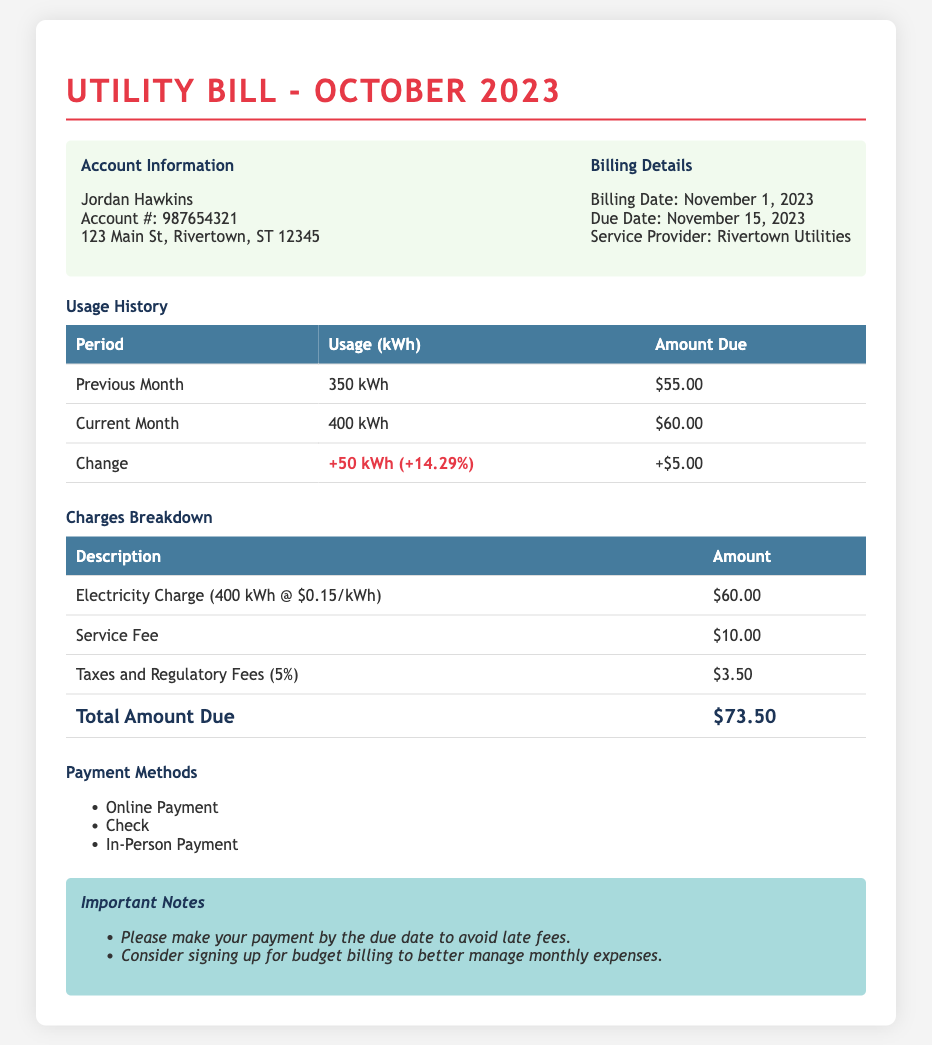What is the account holder's name? The account holder's name is stated in the document as Jordan Hawkins.
Answer: Jordan Hawkins What is the total amount due for October 2023? The total amount due can be found in the Charges Breakdown section as $73.50.
Answer: $73.50 What was the usage in the current month? The document specifies the current month's usage in the Usage History section as 400 kWh.
Answer: 400 kWh What is the due date for the payment? The document clearly states the due date for payment is November 15, 2023.
Answer: November 15, 2023 What percentage is the tax and regulatory fees? The document indicates that the taxes and regulatory fees amount to 5%.
Answer: 5% What was the change in usage from the previous month? The change in usage from the previous month is indicated as +50 kWh (+14.29%).
Answer: +50 kWh (+14.29%) What payment methods are available? The document lists the available payment methods including Online Payment, Check, and In-Person Payment.
Answer: Online Payment, Check, In-Person Payment What is the service fee charged? The service fee, as described in the Charges Breakdown section, is $10.00.
Answer: $10.00 What would happen if the payment is late? The document warns that late fees may be applied if payment is not made by the due date.
Answer: Late fees may apply 